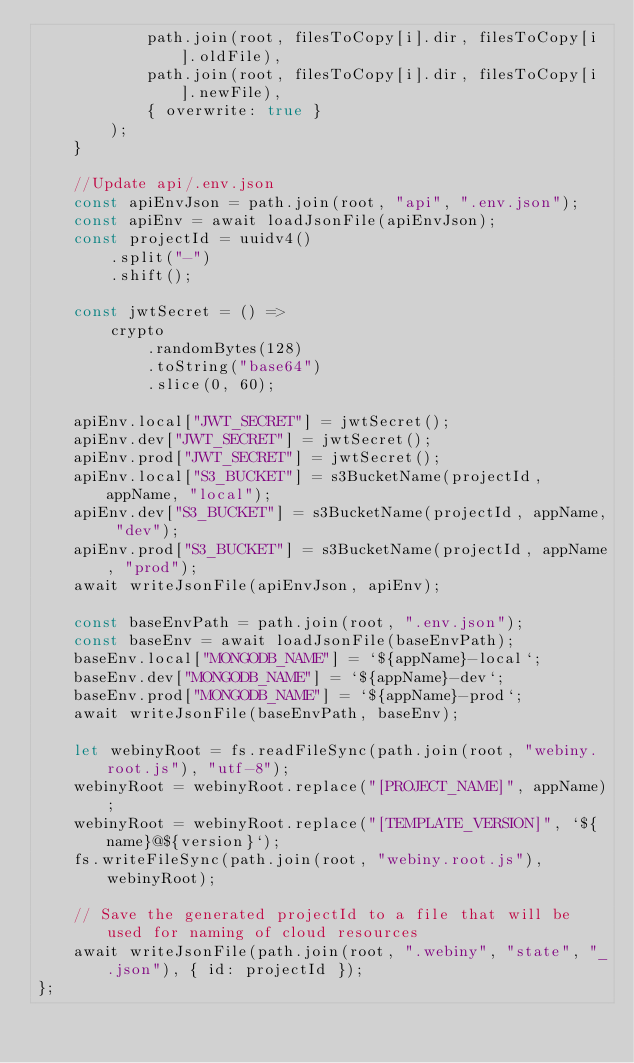<code> <loc_0><loc_0><loc_500><loc_500><_JavaScript_>            path.join(root, filesToCopy[i].dir, filesToCopy[i].oldFile),
            path.join(root, filesToCopy[i].dir, filesToCopy[i].newFile),
            { overwrite: true }
        );
    }

    //Update api/.env.json
    const apiEnvJson = path.join(root, "api", ".env.json");
    const apiEnv = await loadJsonFile(apiEnvJson);
    const projectId = uuidv4()
        .split("-")
        .shift();

    const jwtSecret = () =>
        crypto
            .randomBytes(128)
            .toString("base64")
            .slice(0, 60);

    apiEnv.local["JWT_SECRET"] = jwtSecret();
    apiEnv.dev["JWT_SECRET"] = jwtSecret();
    apiEnv.prod["JWT_SECRET"] = jwtSecret();
    apiEnv.local["S3_BUCKET"] = s3BucketName(projectId, appName, "local");
    apiEnv.dev["S3_BUCKET"] = s3BucketName(projectId, appName, "dev");
    apiEnv.prod["S3_BUCKET"] = s3BucketName(projectId, appName, "prod");
    await writeJsonFile(apiEnvJson, apiEnv);

    const baseEnvPath = path.join(root, ".env.json");
    const baseEnv = await loadJsonFile(baseEnvPath);
    baseEnv.local["MONGODB_NAME"] = `${appName}-local`;
    baseEnv.dev["MONGODB_NAME"] = `${appName}-dev`;
    baseEnv.prod["MONGODB_NAME"] = `${appName}-prod`;
    await writeJsonFile(baseEnvPath, baseEnv);

    let webinyRoot = fs.readFileSync(path.join(root, "webiny.root.js"), "utf-8");
    webinyRoot = webinyRoot.replace("[PROJECT_NAME]", appName);
    webinyRoot = webinyRoot.replace("[TEMPLATE_VERSION]", `${name}@${version}`);
    fs.writeFileSync(path.join(root, "webiny.root.js"), webinyRoot);

    // Save the generated projectId to a file that will be used for naming of cloud resources
    await writeJsonFile(path.join(root, ".webiny", "state", "_.json"), { id: projectId });
};
</code> 